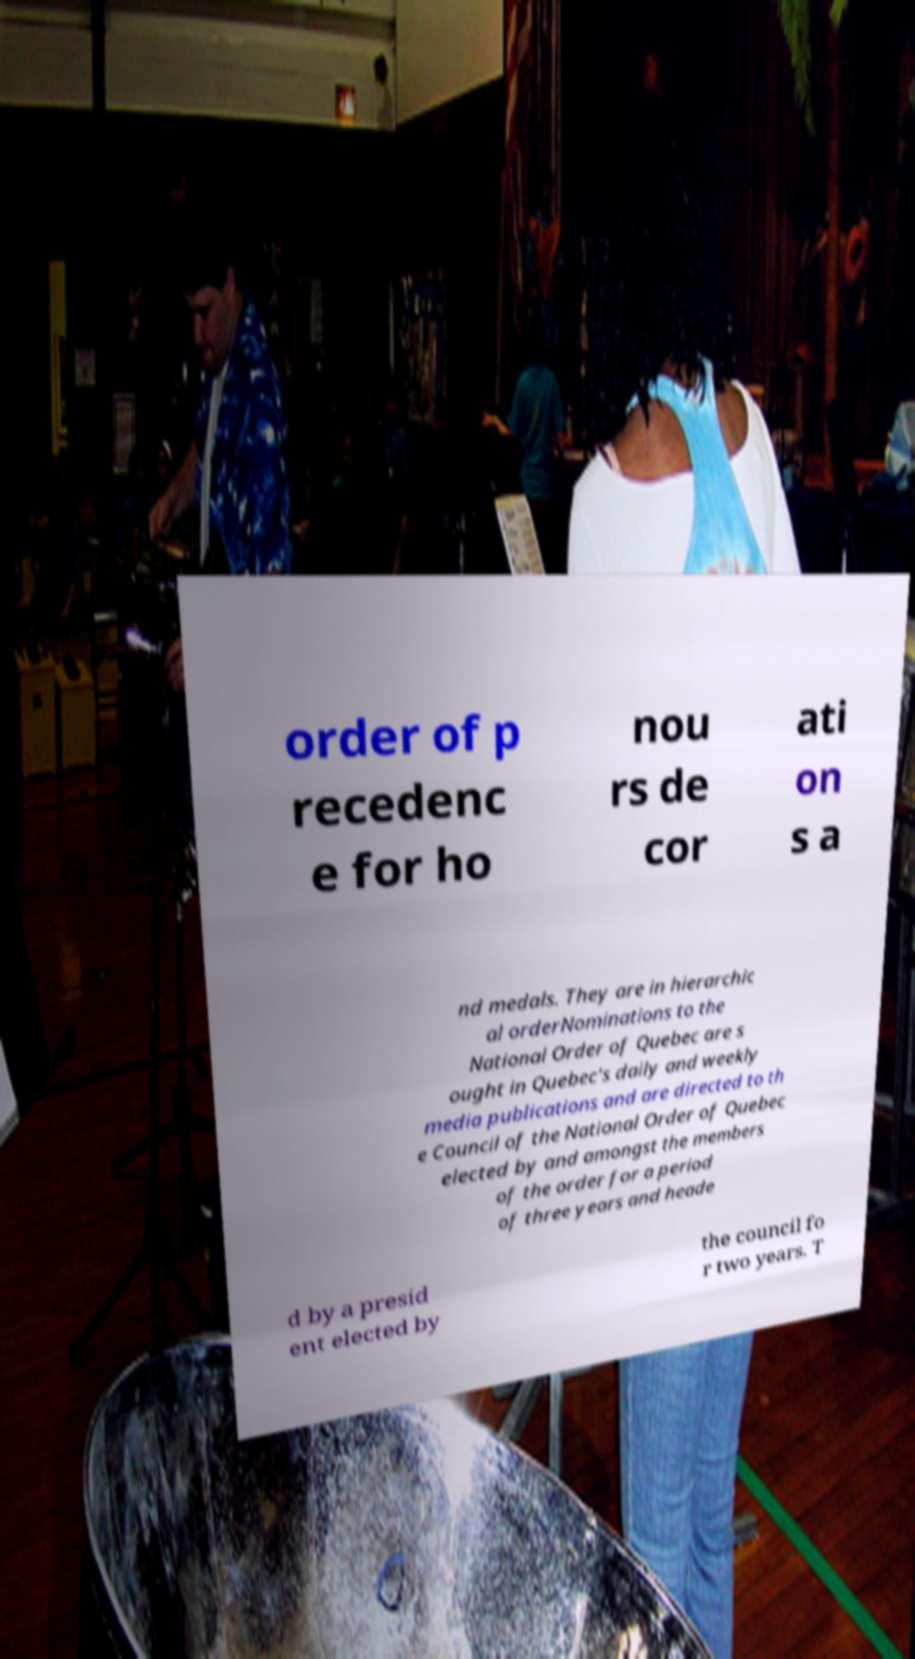Could you assist in decoding the text presented in this image and type it out clearly? order of p recedenc e for ho nou rs de cor ati on s a nd medals. They are in hierarchic al orderNominations to the National Order of Quebec are s ought in Quebec's daily and weekly media publications and are directed to th e Council of the National Order of Quebec elected by and amongst the members of the order for a period of three years and heade d by a presid ent elected by the council fo r two years. T 